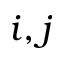Convert formula to latex. <formula><loc_0><loc_0><loc_500><loc_500>i , j</formula> 